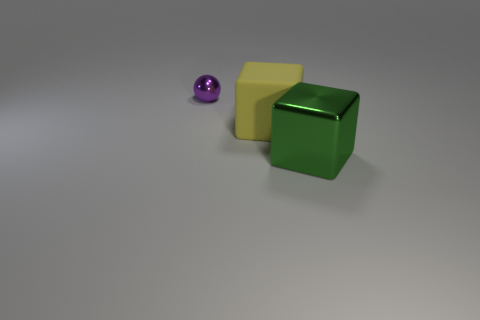There is a metal object behind the green object; is it the same color as the big rubber thing?
Provide a short and direct response. No. Are there any other rubber objects of the same shape as the small purple thing?
Offer a terse response. No. The object that is the same size as the matte block is what color?
Make the answer very short. Green. There is a metal object that is in front of the tiny purple shiny object; what size is it?
Your answer should be compact. Large. There is a metallic object to the right of the small sphere; are there any matte cubes right of it?
Your response must be concise. No. Is the big thing left of the big green metallic object made of the same material as the purple thing?
Offer a terse response. No. What number of objects are both to the left of the big green metal thing and on the right side of the tiny sphere?
Keep it short and to the point. 1. What number of green cubes are made of the same material as the purple ball?
Give a very brief answer. 1. What color is the thing that is the same material as the purple ball?
Offer a very short reply. Green. Is the number of yellow blocks less than the number of big gray blocks?
Offer a very short reply. No. 